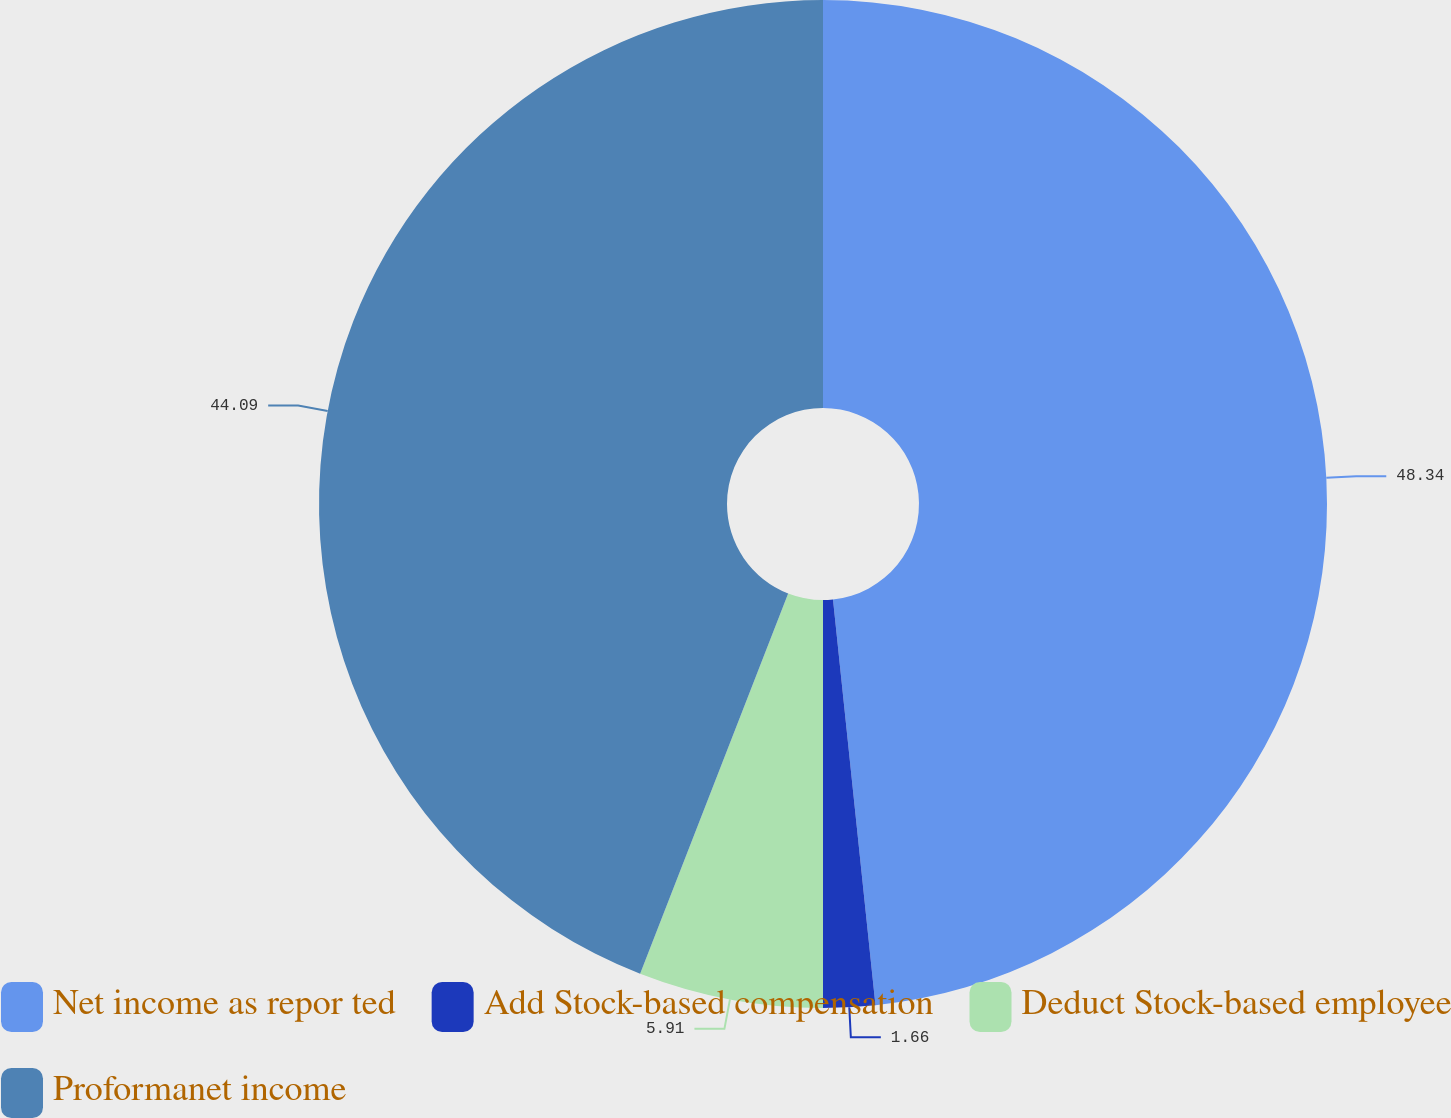Convert chart. <chart><loc_0><loc_0><loc_500><loc_500><pie_chart><fcel>Net income as repor ted<fcel>Add Stock-based compensation<fcel>Deduct Stock-based employee<fcel>Proformanet income<nl><fcel>48.34%<fcel>1.66%<fcel>5.91%<fcel>44.09%<nl></chart> 